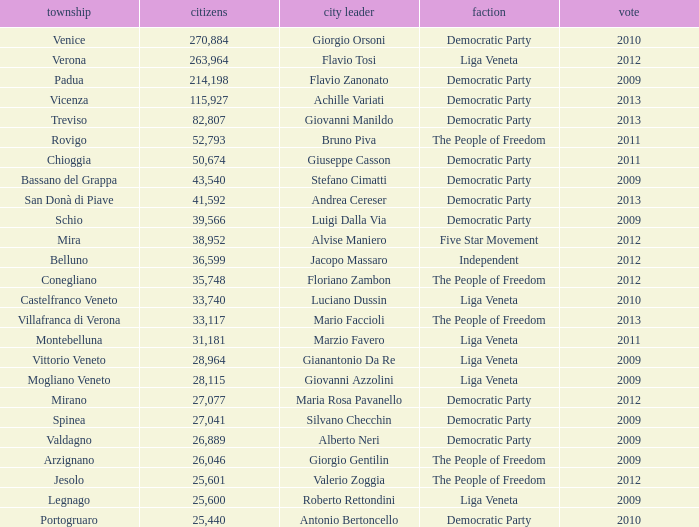How many Inhabitants were in the democratic party for an election before 2009 for Mayor of stefano cimatti? 0.0. 